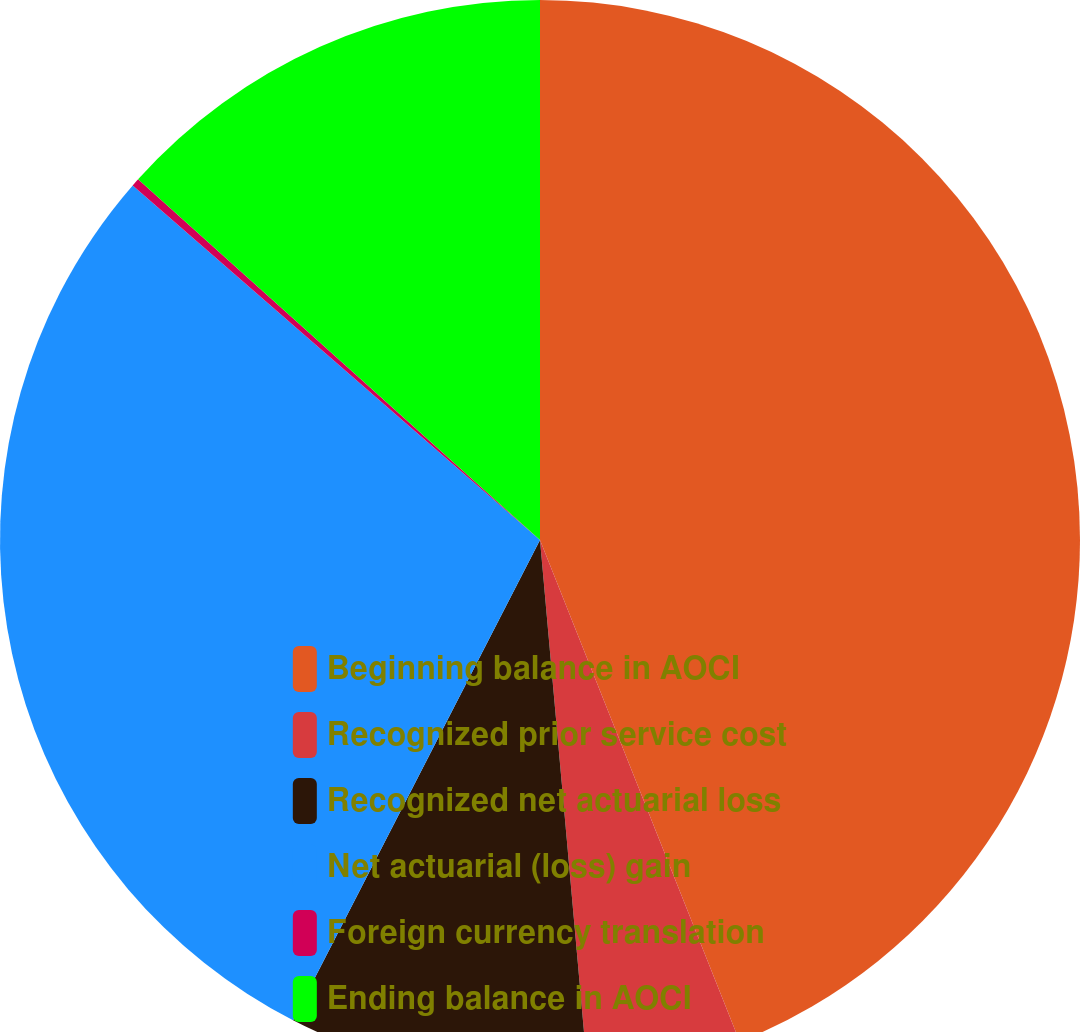<chart> <loc_0><loc_0><loc_500><loc_500><pie_chart><fcel>Beginning balance in AOCI<fcel>Recognized prior service cost<fcel>Recognized net actuarial loss<fcel>Net actuarial (loss) gain<fcel>Foreign currency translation<fcel>Ending balance in AOCI<nl><fcel>43.97%<fcel>4.61%<fcel>8.98%<fcel>28.84%<fcel>0.24%<fcel>13.36%<nl></chart> 